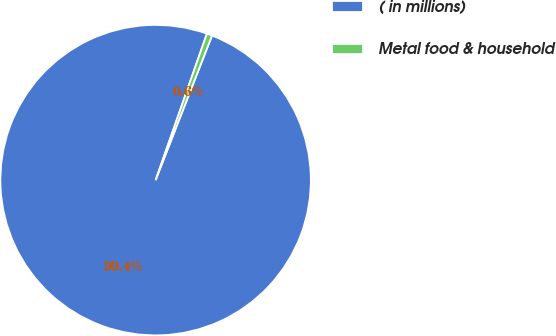Convert chart to OTSL. <chart><loc_0><loc_0><loc_500><loc_500><pie_chart><fcel>( in millions)<fcel>Metal food & household<nl><fcel>99.44%<fcel>0.56%<nl></chart> 